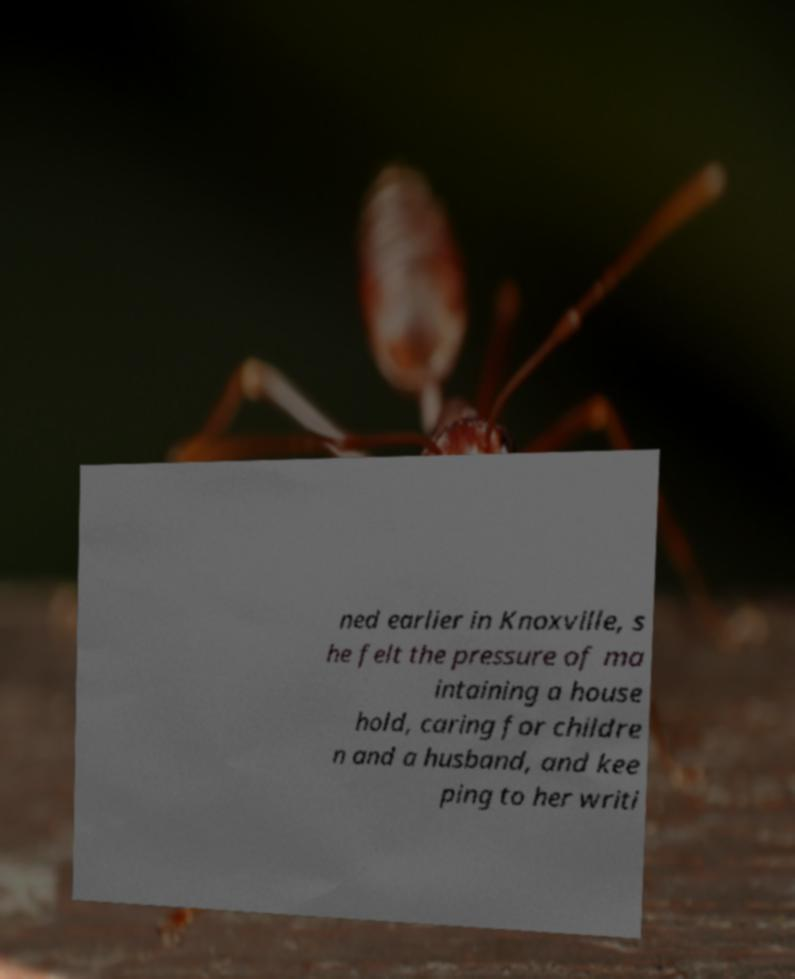I need the written content from this picture converted into text. Can you do that? ned earlier in Knoxville, s he felt the pressure of ma intaining a house hold, caring for childre n and a husband, and kee ping to her writi 